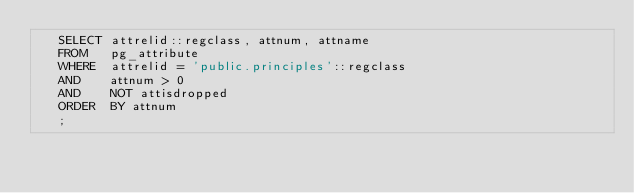<code> <loc_0><loc_0><loc_500><loc_500><_SQL_>   SELECT attrelid::regclass, attnum, attname
   FROM   pg_attribute
   WHERE  attrelid = 'public.principles'::regclass
   AND    attnum > 0
   AND    NOT attisdropped
   ORDER  BY attnum
   ; 
</code> 